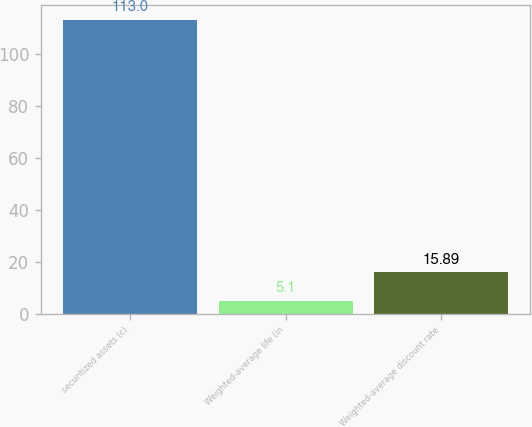Convert chart. <chart><loc_0><loc_0><loc_500><loc_500><bar_chart><fcel>securitized assets (c)<fcel>Weighted-average life (in<fcel>Weighted-average discount rate<nl><fcel>113<fcel>5.1<fcel>15.89<nl></chart> 